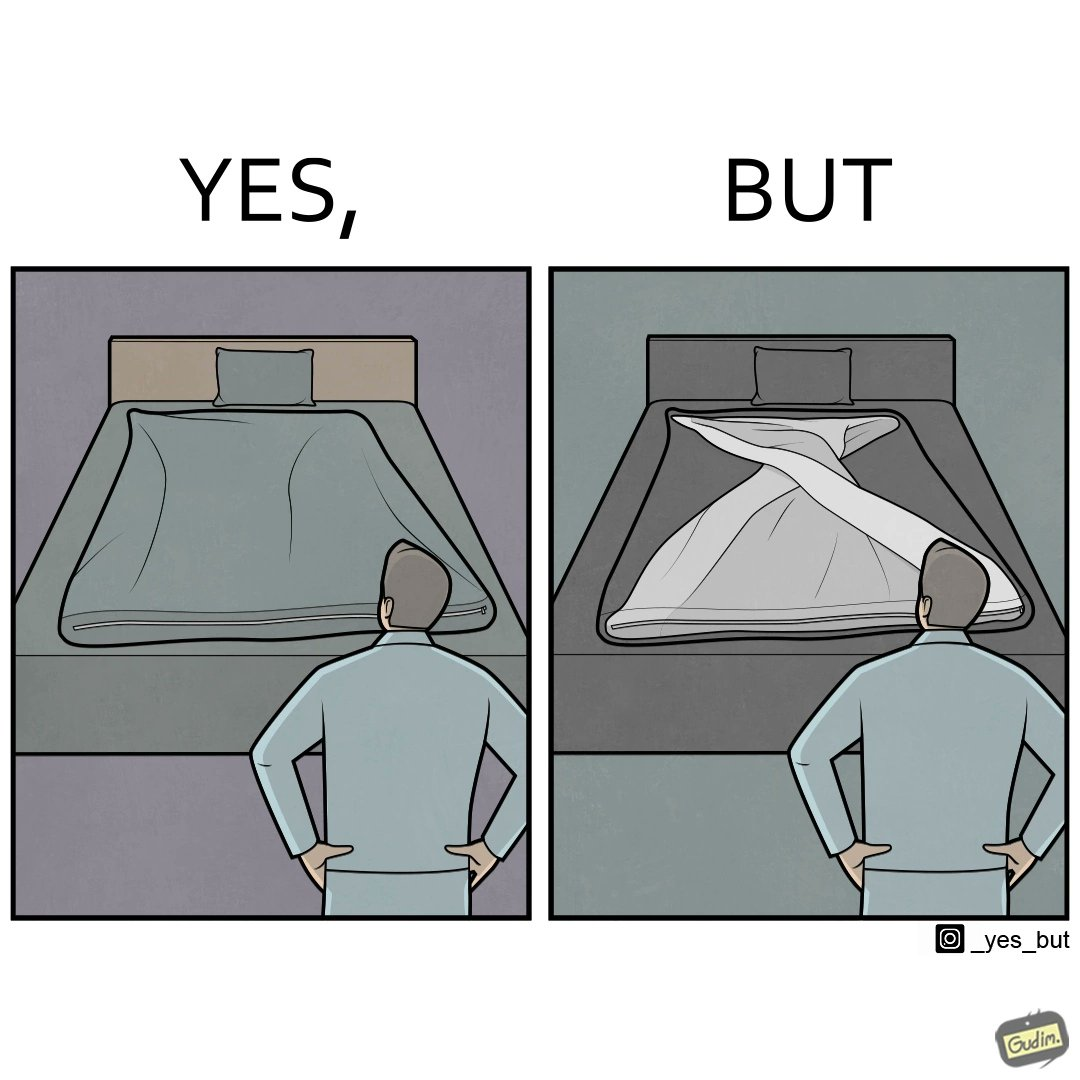What is shown in the left half versus the right half of this image? In the left part of the image: The image shows a man looking at his bed. His bed seems well made with blanket and pillow properly arranged on the mattress. In the right part of the image: The image shows a man looking at his bed. The image also shows the actual blanket inside its cover on the bed. The blanked is all twisted inside the cover and is not properly set. 